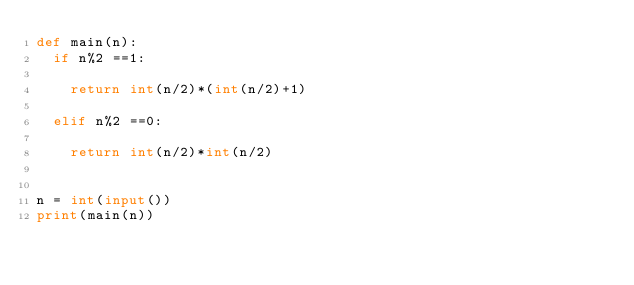Convert code to text. <code><loc_0><loc_0><loc_500><loc_500><_Python_>def main(n):
	if n%2 ==1:
		
		return int(n/2)*(int(n/2)+1)
		
	elif n%2 ==0:
		
		return int(n/2)*int(n/2)


n = int(input())
print(main(n))</code> 